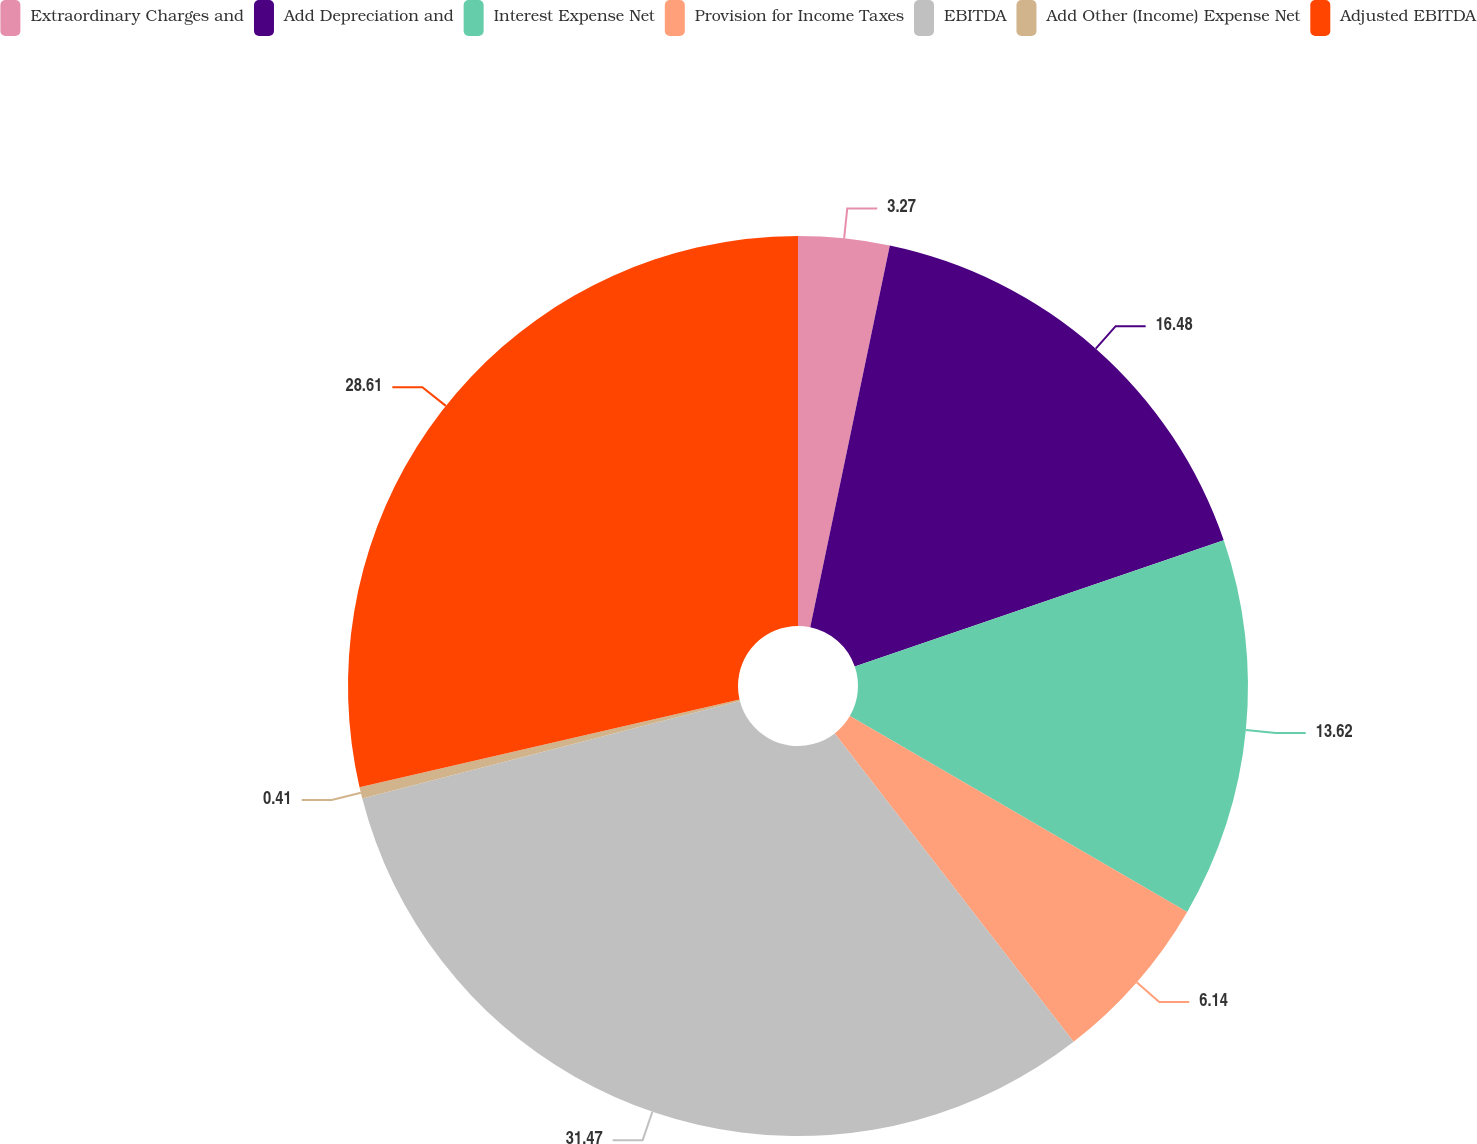Convert chart to OTSL. <chart><loc_0><loc_0><loc_500><loc_500><pie_chart><fcel>Extraordinary Charges and<fcel>Add Depreciation and<fcel>Interest Expense Net<fcel>Provision for Income Taxes<fcel>EBITDA<fcel>Add Other (Income) Expense Net<fcel>Adjusted EBITDA<nl><fcel>3.27%<fcel>16.48%<fcel>13.62%<fcel>6.14%<fcel>31.47%<fcel>0.41%<fcel>28.61%<nl></chart> 